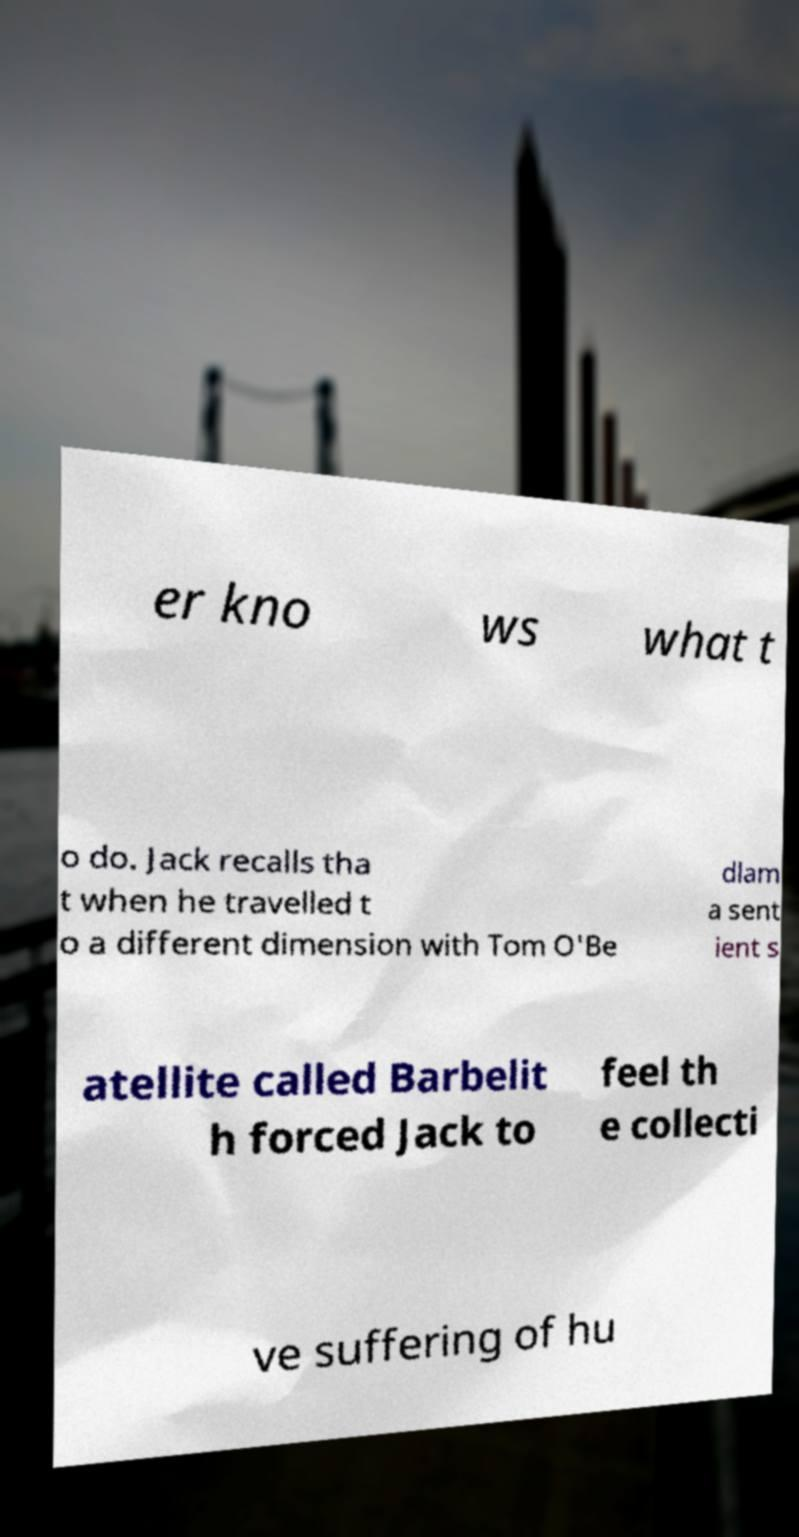Could you assist in decoding the text presented in this image and type it out clearly? er kno ws what t o do. Jack recalls tha t when he travelled t o a different dimension with Tom O'Be dlam a sent ient s atellite called Barbelit h forced Jack to feel th e collecti ve suffering of hu 